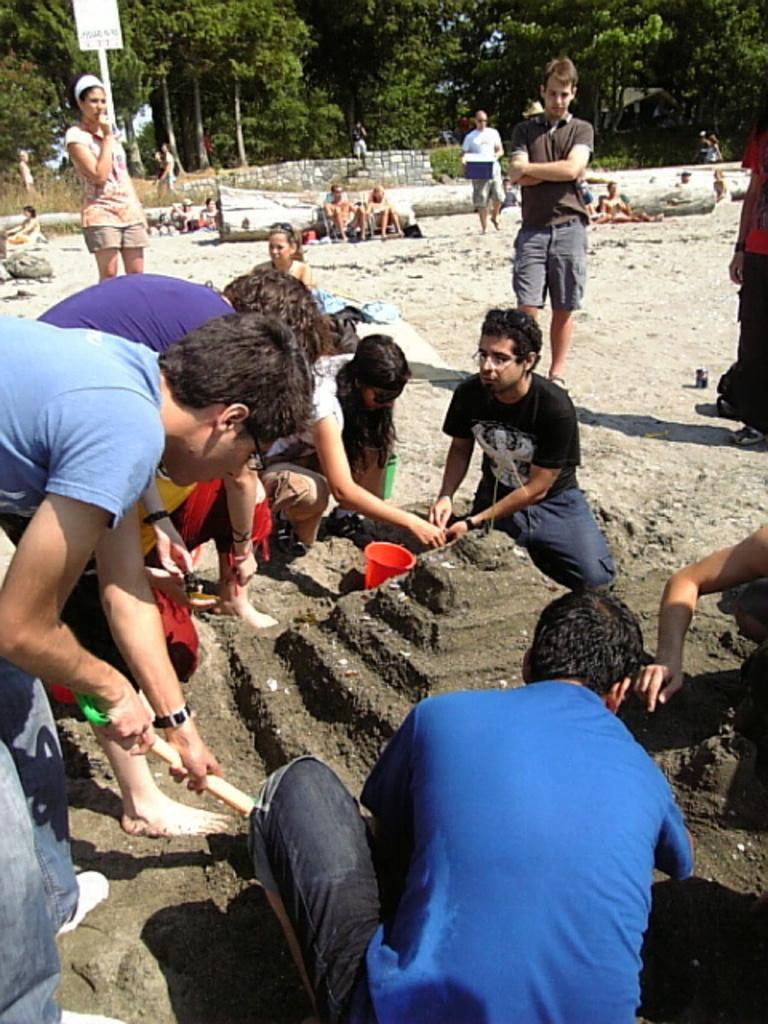What are the people in the image doing? The people in the image are constructing something with sand. Can you describe the activity taking place in the image? The people are working together to create a sand structure. What can be seen in the background of the image? There are other people visible in the background, as well as trees. What type of letters are being delivered by the station in the image? There is no station or letters present in the image; it features a group of people constructing something with sand. How many oranges are visible on the sand structure in the image? There are no oranges present in the image; it features a group of people constructing something with sand. 